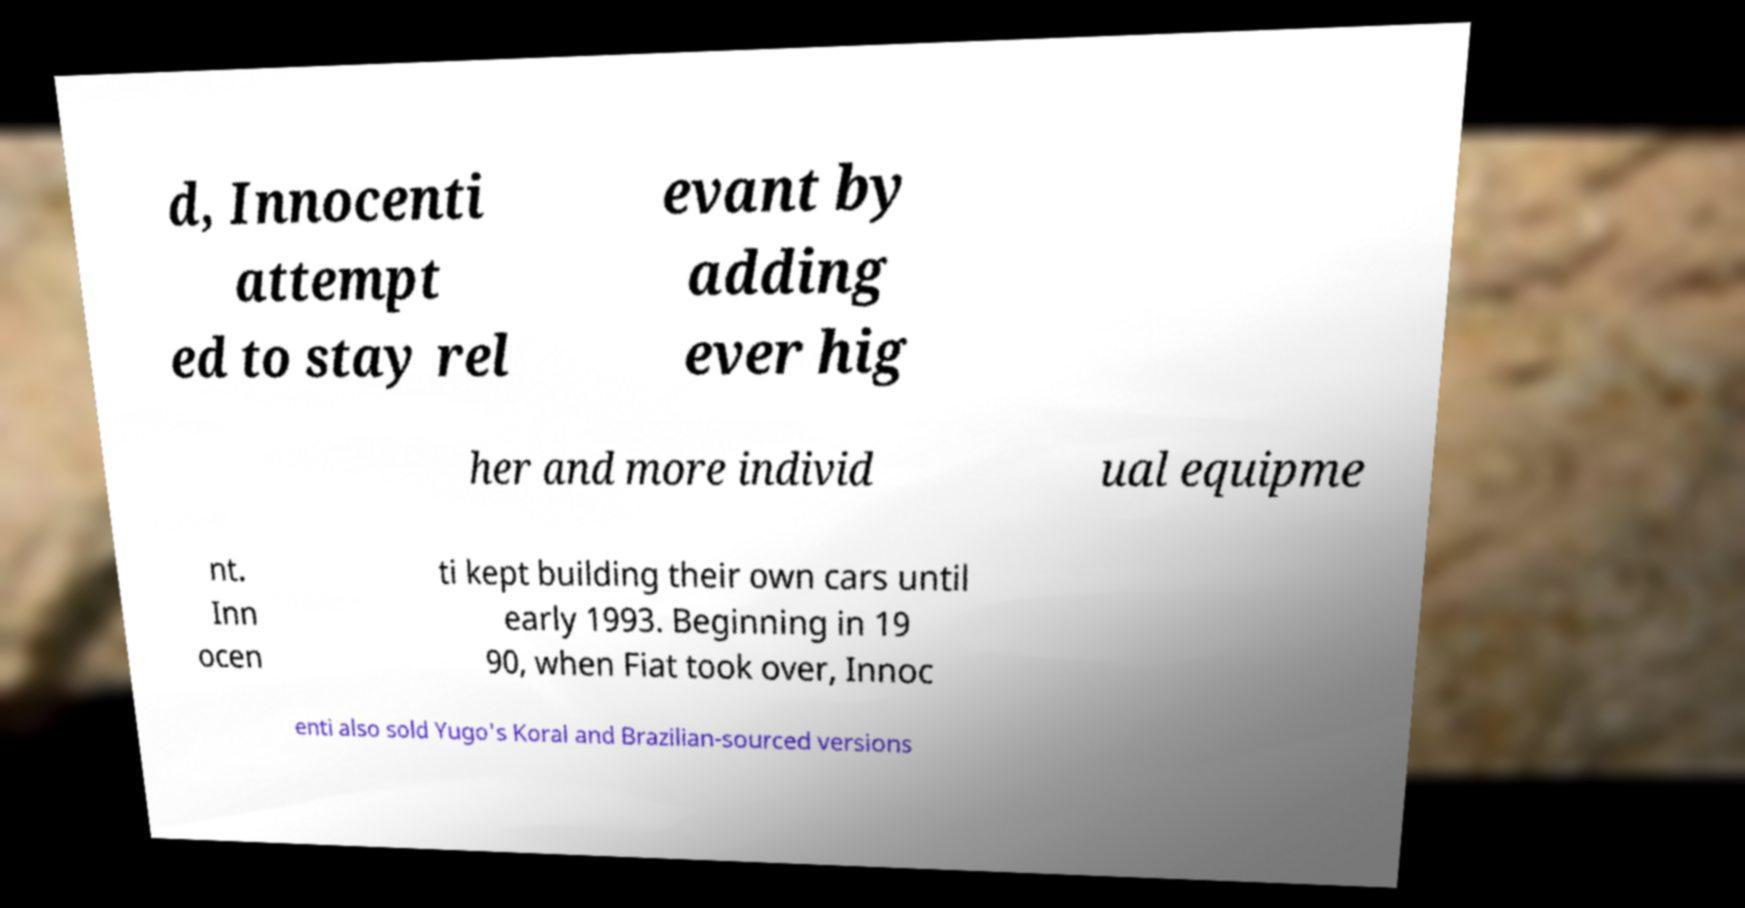There's text embedded in this image that I need extracted. Can you transcribe it verbatim? d, Innocenti attempt ed to stay rel evant by adding ever hig her and more individ ual equipme nt. Inn ocen ti kept building their own cars until early 1993. Beginning in 19 90, when Fiat took over, Innoc enti also sold Yugo's Koral and Brazilian-sourced versions 